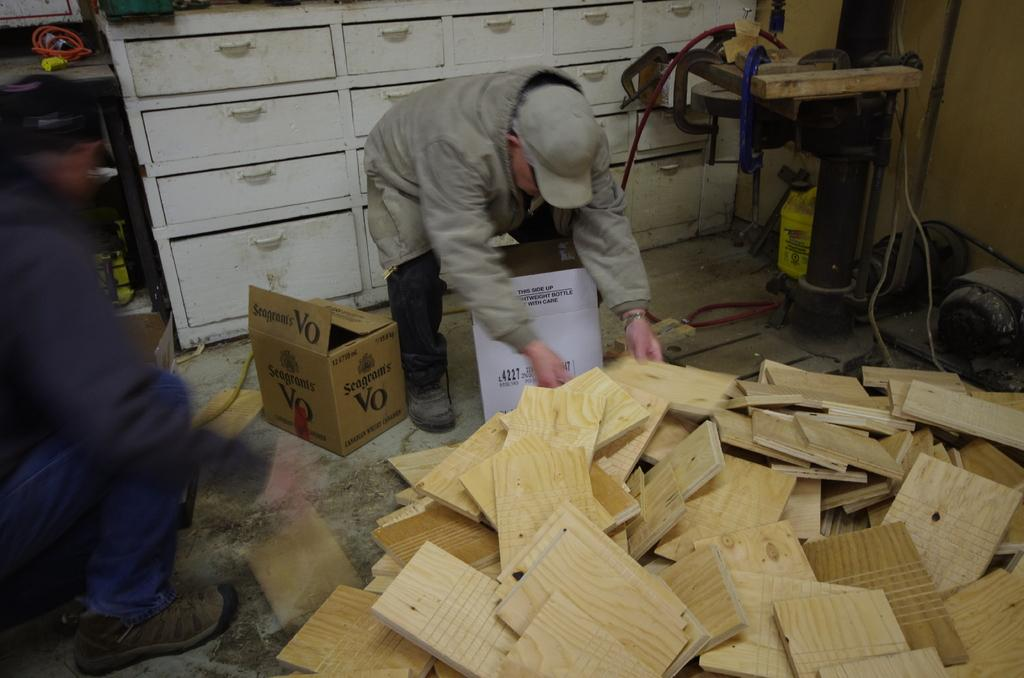How many people are in the image? There are two persons in the image. What can be seen on the floor in the image? There are cardboard boxes and wooden sheets on the floor. What is located on the floor besides the cardboard boxes and wooden sheets? There is a machine on the floor. What can be seen in the background of the image? There are drawers visible in the background, along with other objects. What type of rod is being used to attack the houses in the image? There are no houses or attacks present in the image; it features two persons, cardboard boxes, wooden sheets, a machine, drawers, and other objects. 